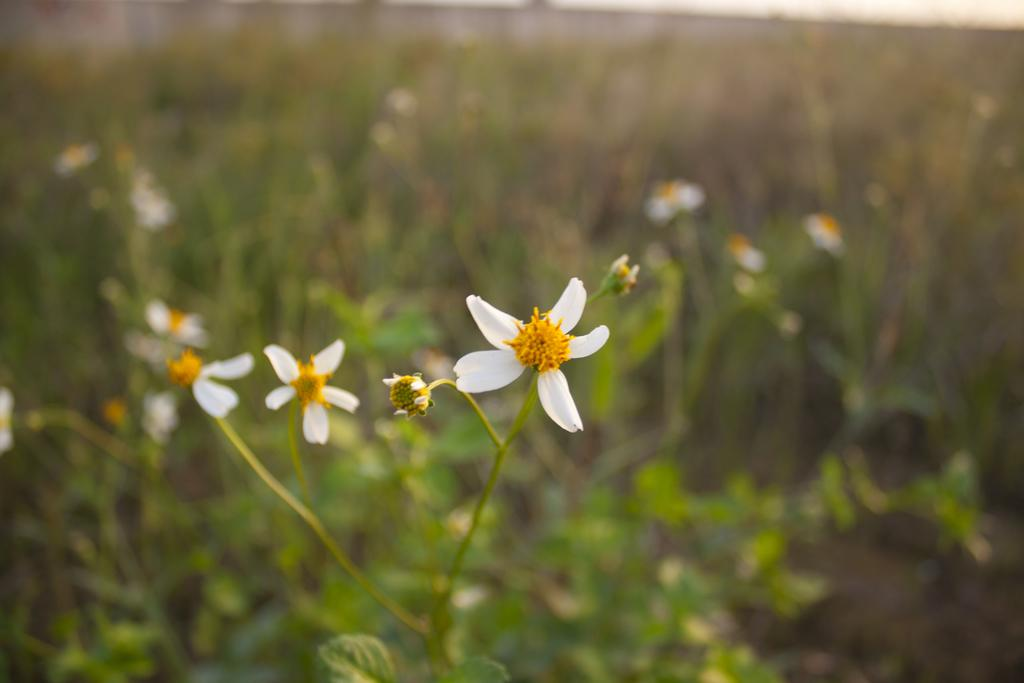What type of flora can be seen in the image? There are flowers in the image. What colors are the flowers? The flowers are white and yellow in color. What else can be seen in the background of the image? There are plants and leaves in the background of the image. Is there a sail visible in the image? No, there is no sail present in the image. Is it raining in the image? The image does not show any indication of rain, so it cannot be determined from the image alone. 